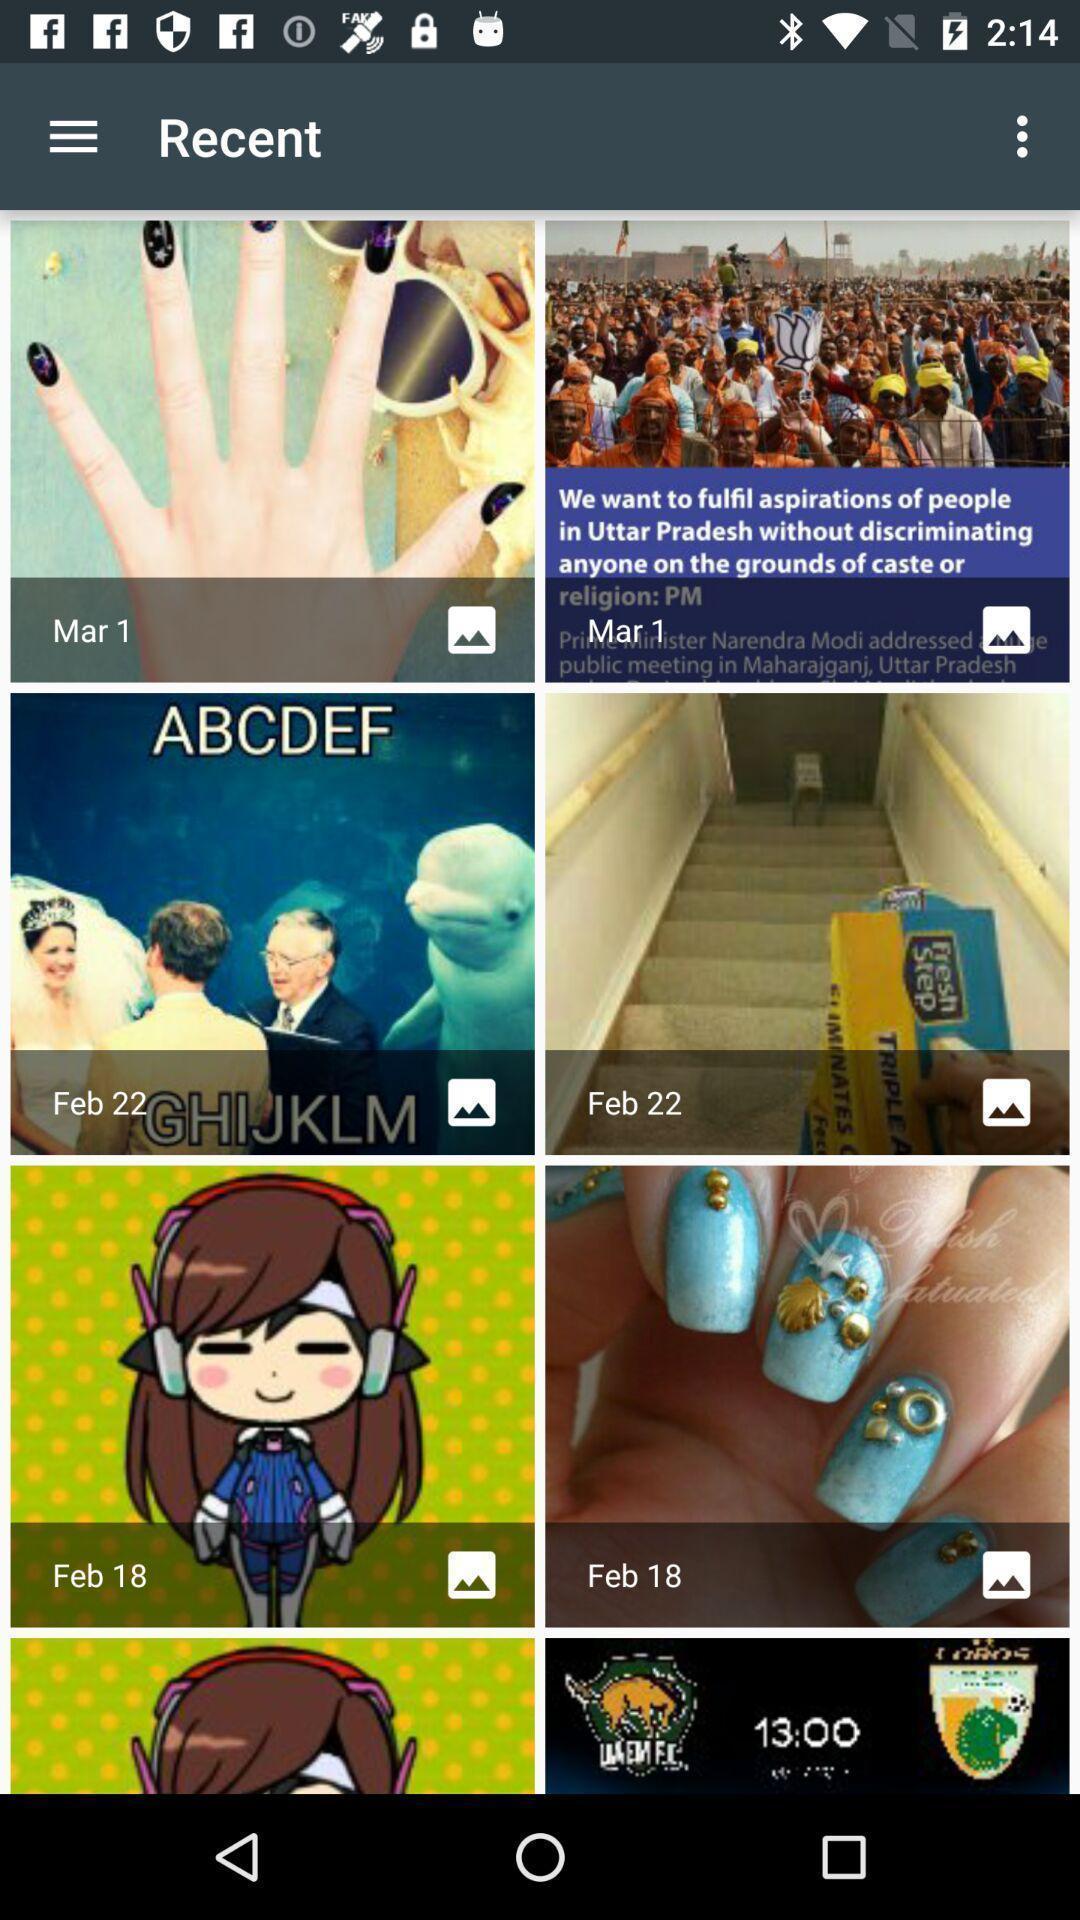Give me a summary of this screen capture. Result for recent in an social application with some images. 